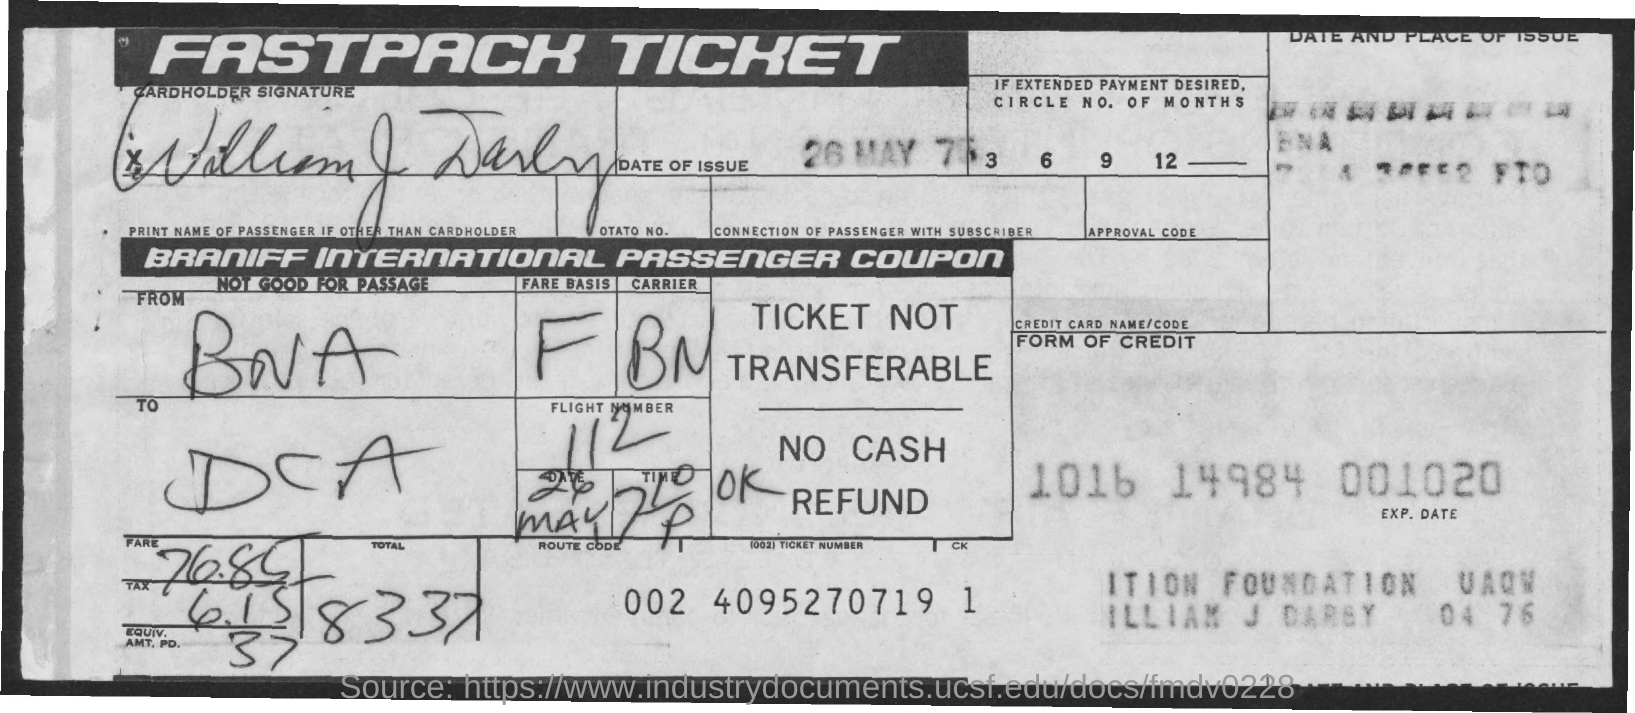When is the Date of issue?
Provide a short and direct response. 26 MAY 75. Where is the "From"?
Provide a succinct answer. BNA. Where is the "To"?
Your answer should be very brief. DCA. Which is the carrier?
Offer a terse response. BN. What is the Flight Number?
Your answer should be very brief. 112. What is the fare?
Provide a short and direct response. 76.85. What is the Tax?
Your response must be concise. 6.15. What is the Total?
Offer a very short reply. 83.37. 